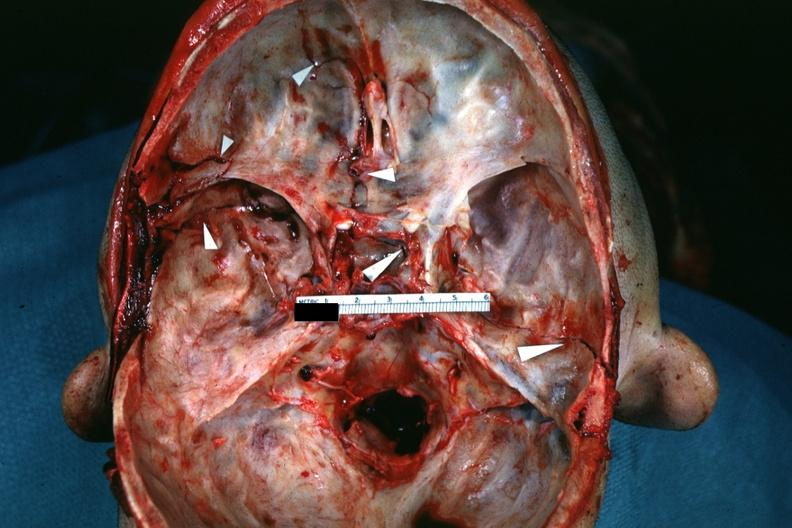s intraductal papillomatosis with apocrine metaplasia present?
Answer the question using a single word or phrase. No 